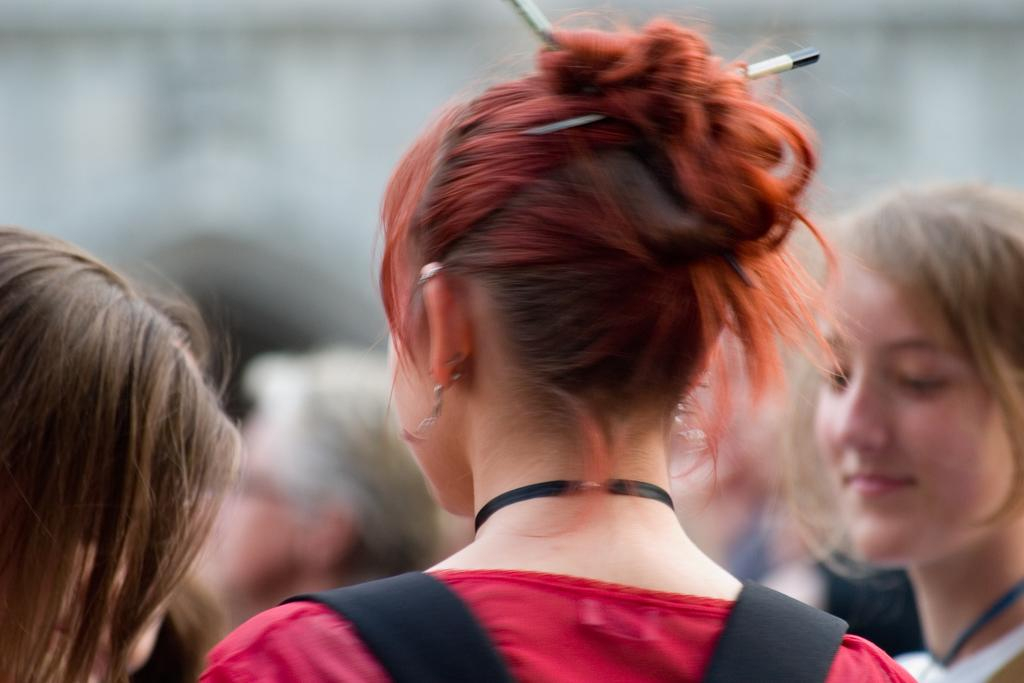What is the main subject of the image? The main subject of the image is a group of people. Can you describe the appearance of one person in the group? One person in the group is wearing a red color dress. How would you describe the background of the image? The background of the image is blurred. What type of yarn is being used by the person in the red dress in the image? There is no yarn present in the image, and therefore no such activity can be observed. 